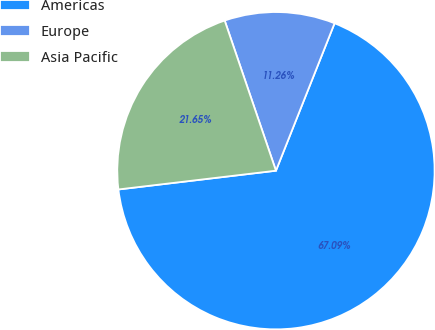<chart> <loc_0><loc_0><loc_500><loc_500><pie_chart><fcel>Americas<fcel>Europe<fcel>Asia Pacific<nl><fcel>67.09%<fcel>11.26%<fcel>21.65%<nl></chart> 